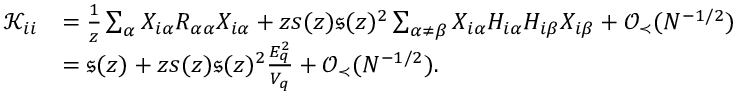Convert formula to latex. <formula><loc_0><loc_0><loc_500><loc_500>\begin{array} { r l } { { \mathcal { K } } _ { i i } } & { = \frac { 1 } { z } \sum _ { \alpha } X _ { i \alpha } R _ { \alpha \alpha } X _ { i \alpha } + z s ( z ) \mathfrak { s } ( z ) ^ { 2 } \sum _ { \alpha \neq \beta } X _ { i \alpha } H _ { i \alpha } H _ { i \beta } X _ { i \beta } + { \mathcal { O } } _ { \prec } ( N ^ { - 1 / 2 } ) } \\ & { = \mathfrak { s } ( z ) + z s ( z ) \mathfrak { s } ( z ) ^ { 2 } \frac { E _ { q } ^ { 2 } } { V _ { q } } + { \mathcal { O } } _ { \prec } ( N ^ { - 1 / 2 } ) . } \end{array}</formula> 